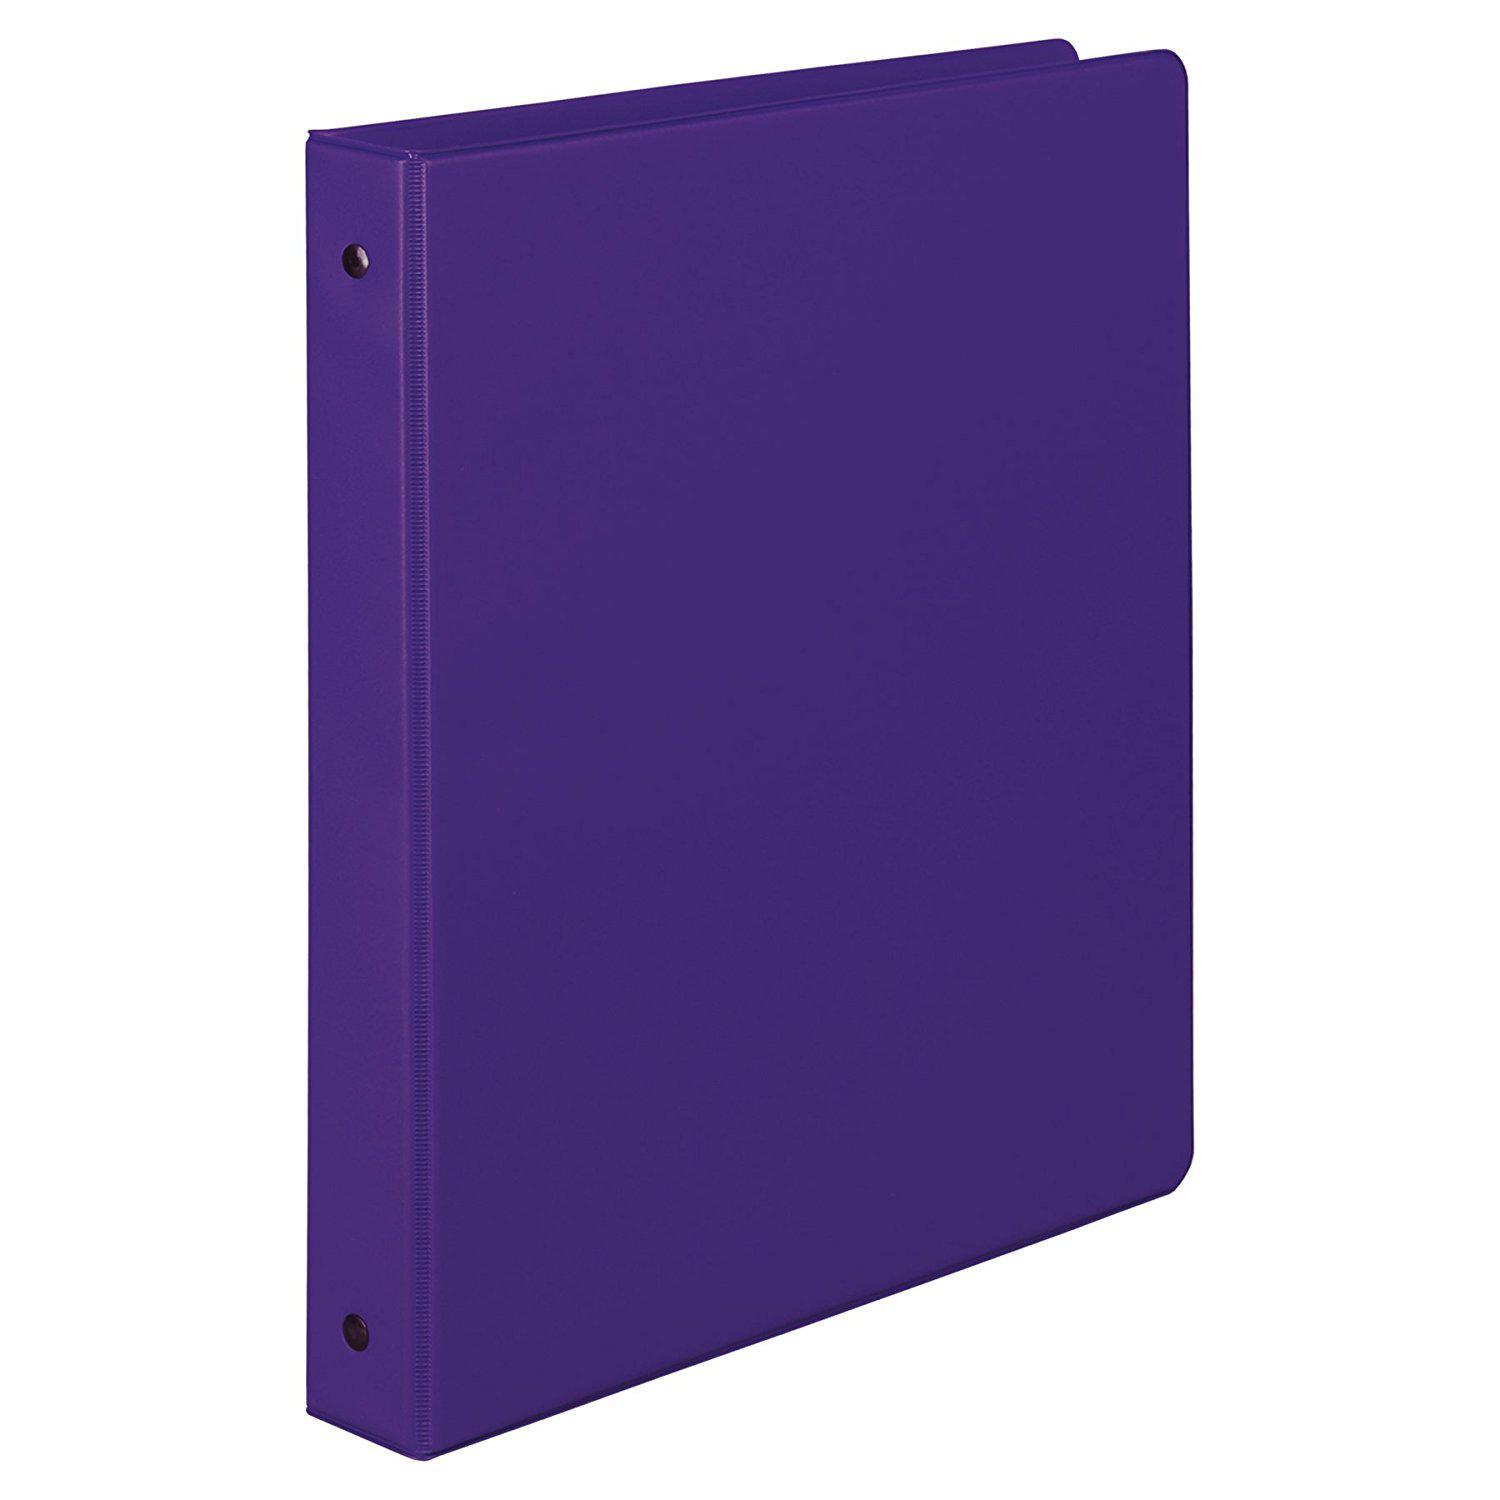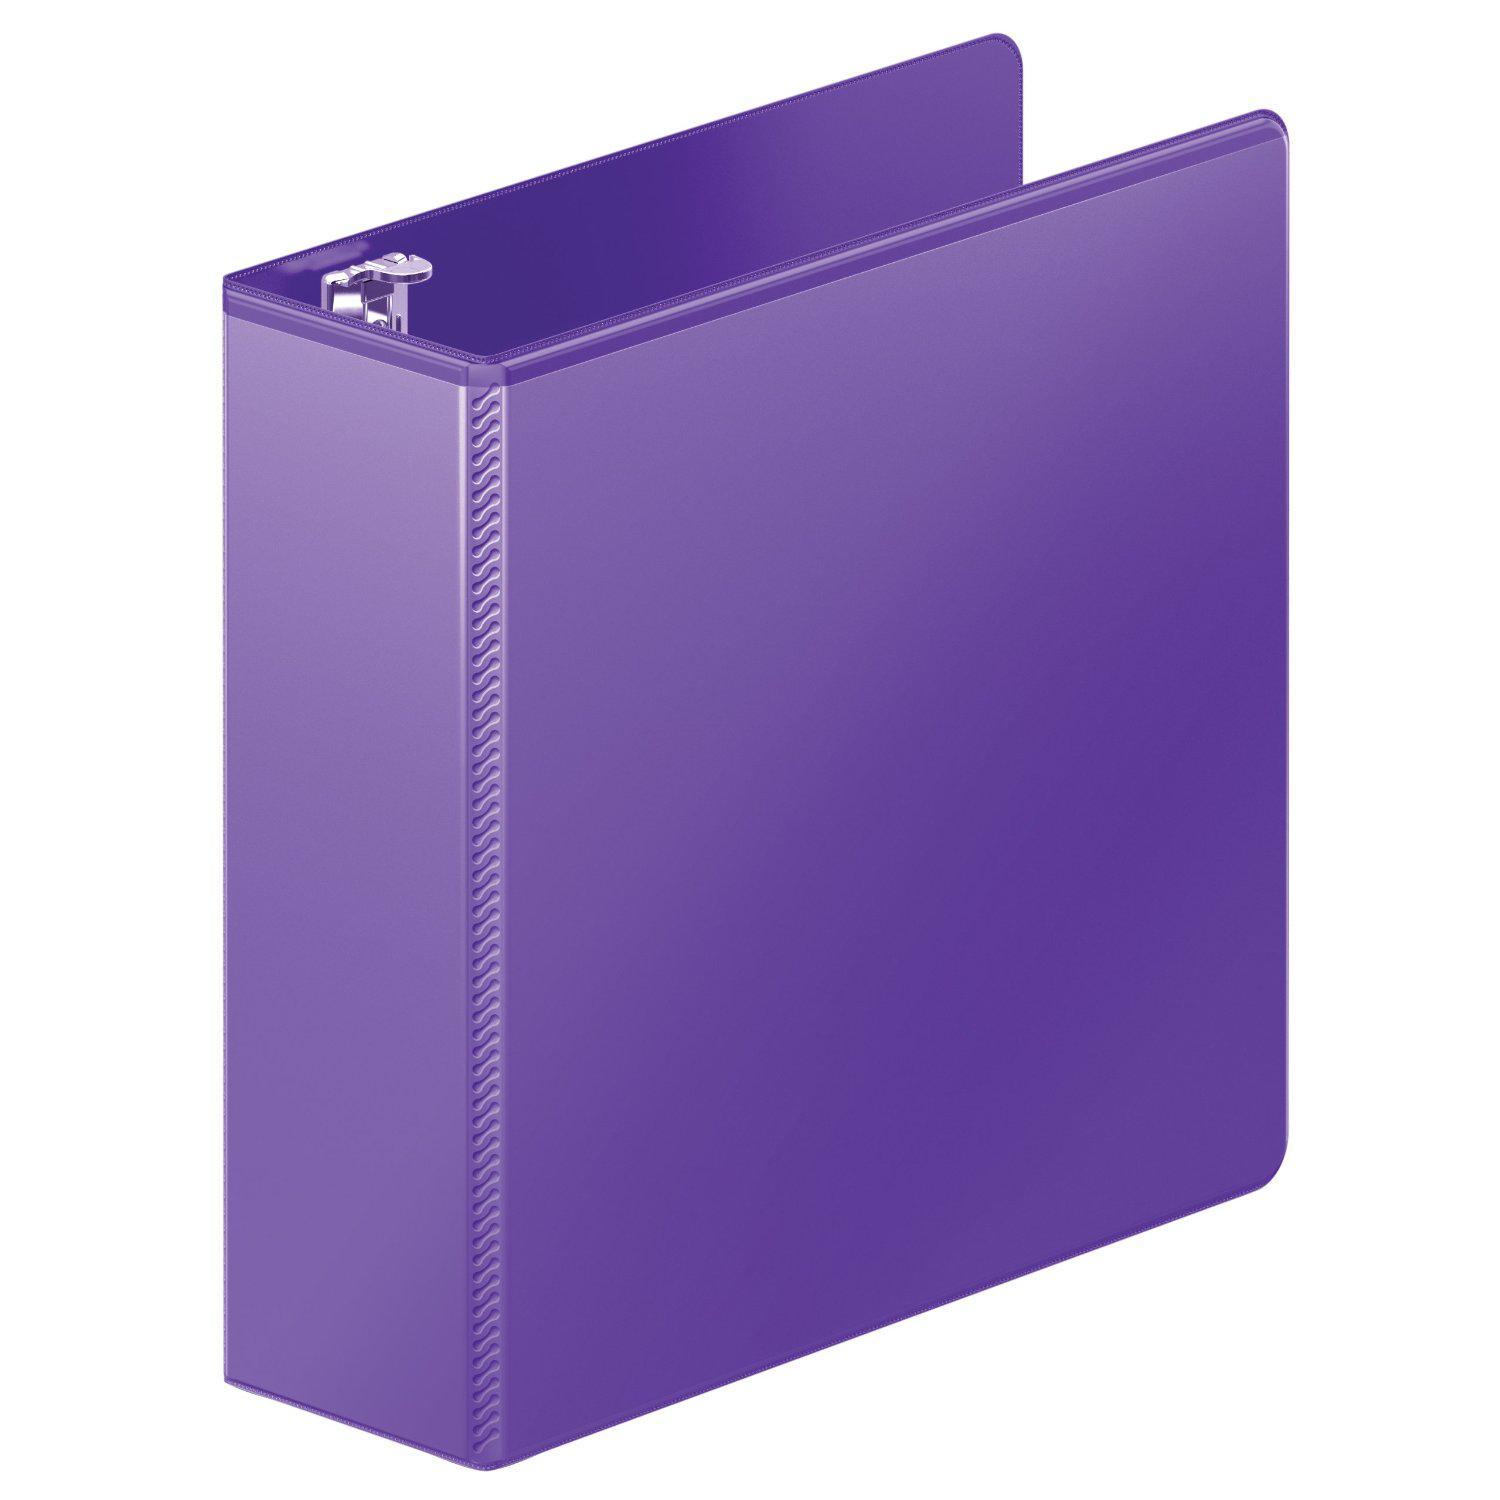The first image is the image on the left, the second image is the image on the right. Evaluate the accuracy of this statement regarding the images: "Two solid purple binder notebooks are shown in a similar stance, on end with the opening to the back, and have no visible contents.". Is it true? Answer yes or no. Yes. The first image is the image on the left, the second image is the image on the right. Given the left and right images, does the statement "Both binders are purple." hold true? Answer yes or no. Yes. 